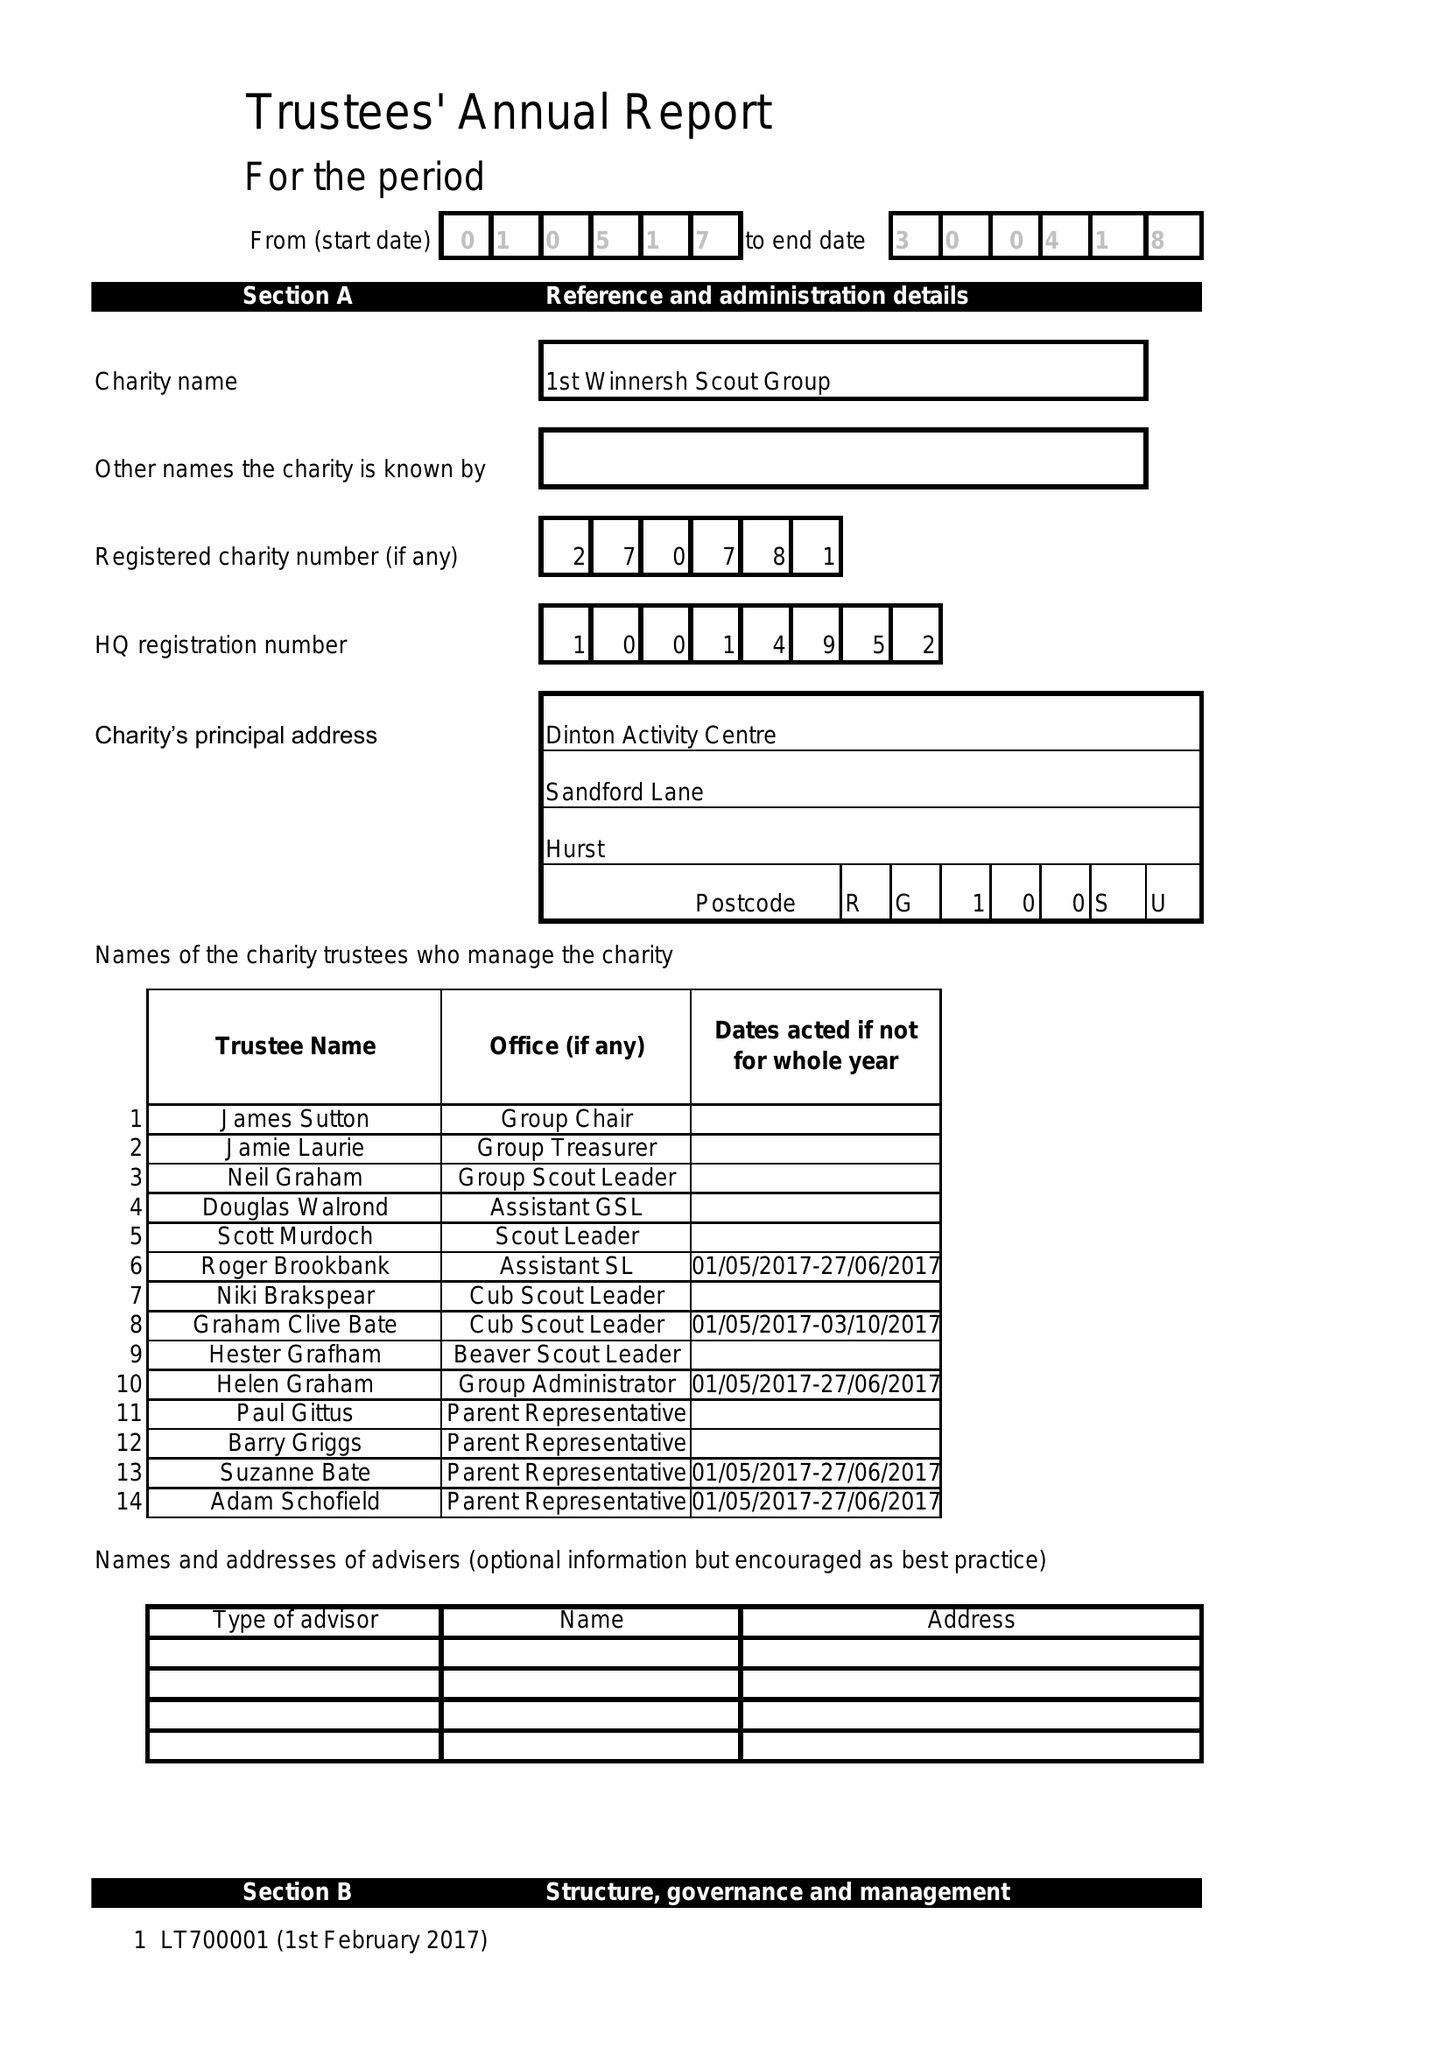What is the value for the charity_number?
Answer the question using a single word or phrase. 270781 